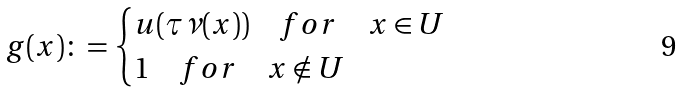<formula> <loc_0><loc_0><loc_500><loc_500>g ( x ) \colon = \begin{cases} u ( \tau \nu ( x ) ) \quad f o r \quad x \in U \\ 1 \quad f o r \quad x \notin U \end{cases}</formula> 